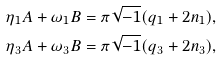<formula> <loc_0><loc_0><loc_500><loc_500>& \eta _ { 1 } A + \omega _ { 1 } B = \pi \sqrt { - 1 } ( q _ { 1 } + 2 n _ { 1 } ) , \\ & \eta _ { 3 } A + \omega _ { 3 } B = \pi \sqrt { - 1 } ( q _ { 3 } + 2 n _ { 3 } ) ,</formula> 